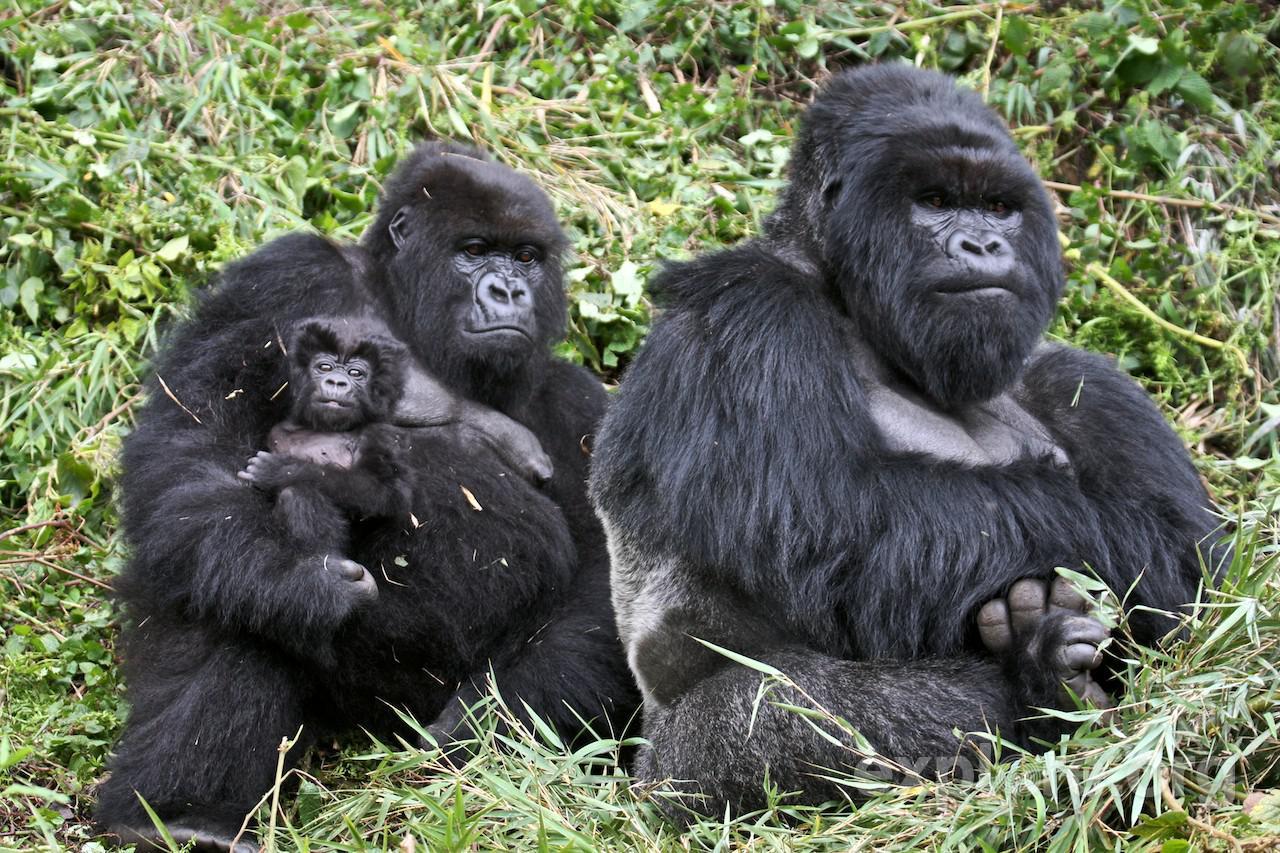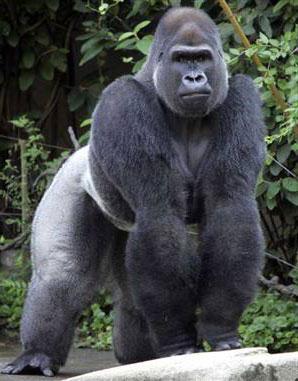The first image is the image on the left, the second image is the image on the right. Given the left and right images, does the statement "One image includes a baby gorilla with its mother." hold true? Answer yes or no. Yes. 